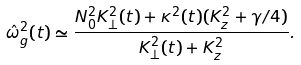<formula> <loc_0><loc_0><loc_500><loc_500>\hat { \omega } _ { g } ^ { 2 } ( t ) \simeq \frac { N _ { 0 } ^ { 2 } K _ { \perp } ^ { 2 } ( t ) + \kappa ^ { 2 } ( t ) ( K _ { z } ^ { 2 } + \gamma / 4 ) } { K _ { \perp } ^ { 2 } ( t ) + K _ { z } ^ { 2 } } .</formula> 